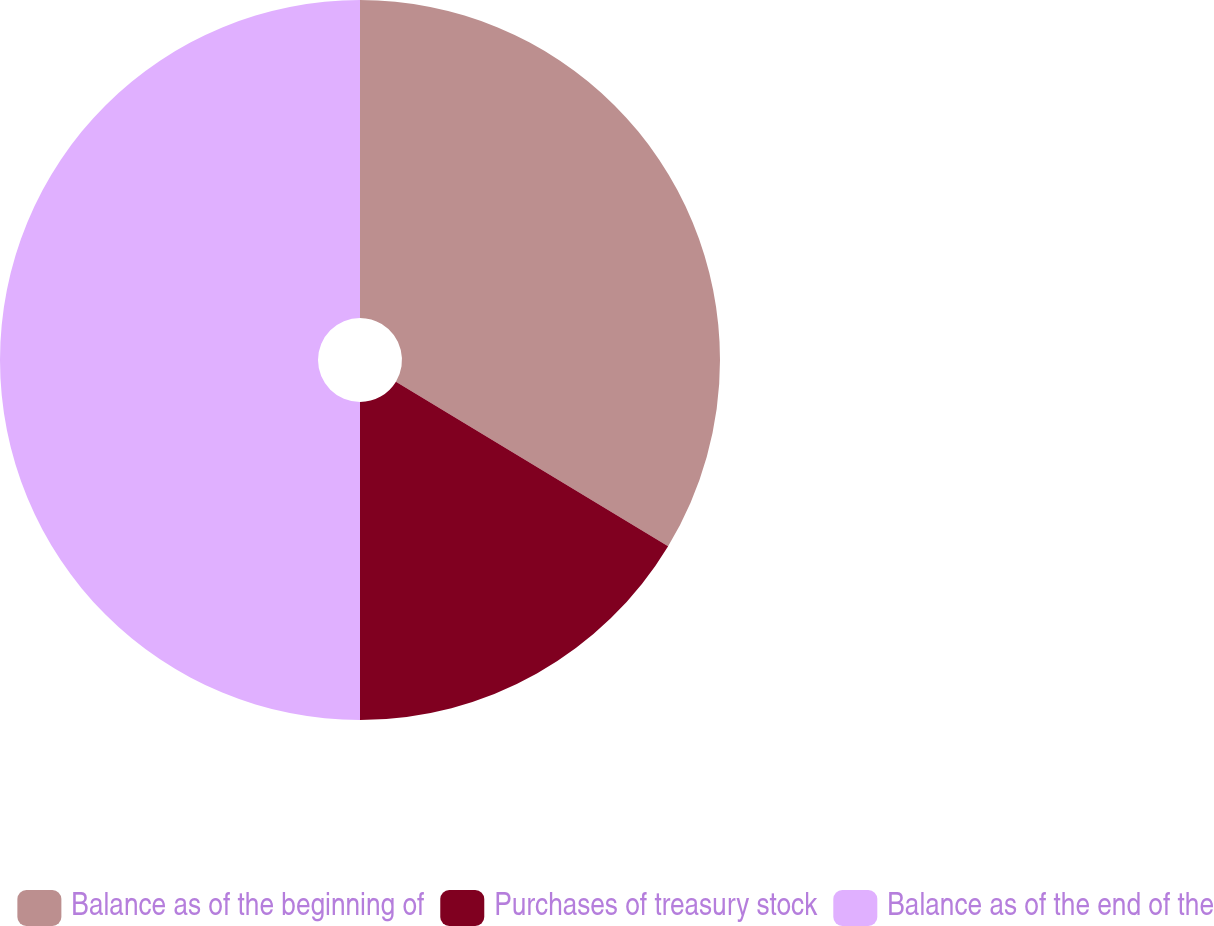<chart> <loc_0><loc_0><loc_500><loc_500><pie_chart><fcel>Balance as of the beginning of<fcel>Purchases of treasury stock<fcel>Balance as of the end of the<nl><fcel>33.65%<fcel>16.35%<fcel>50.0%<nl></chart> 